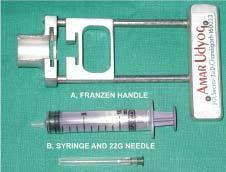what is equipments required for?
Answer the question using a single word or phrase. Transcutaneous fnac 